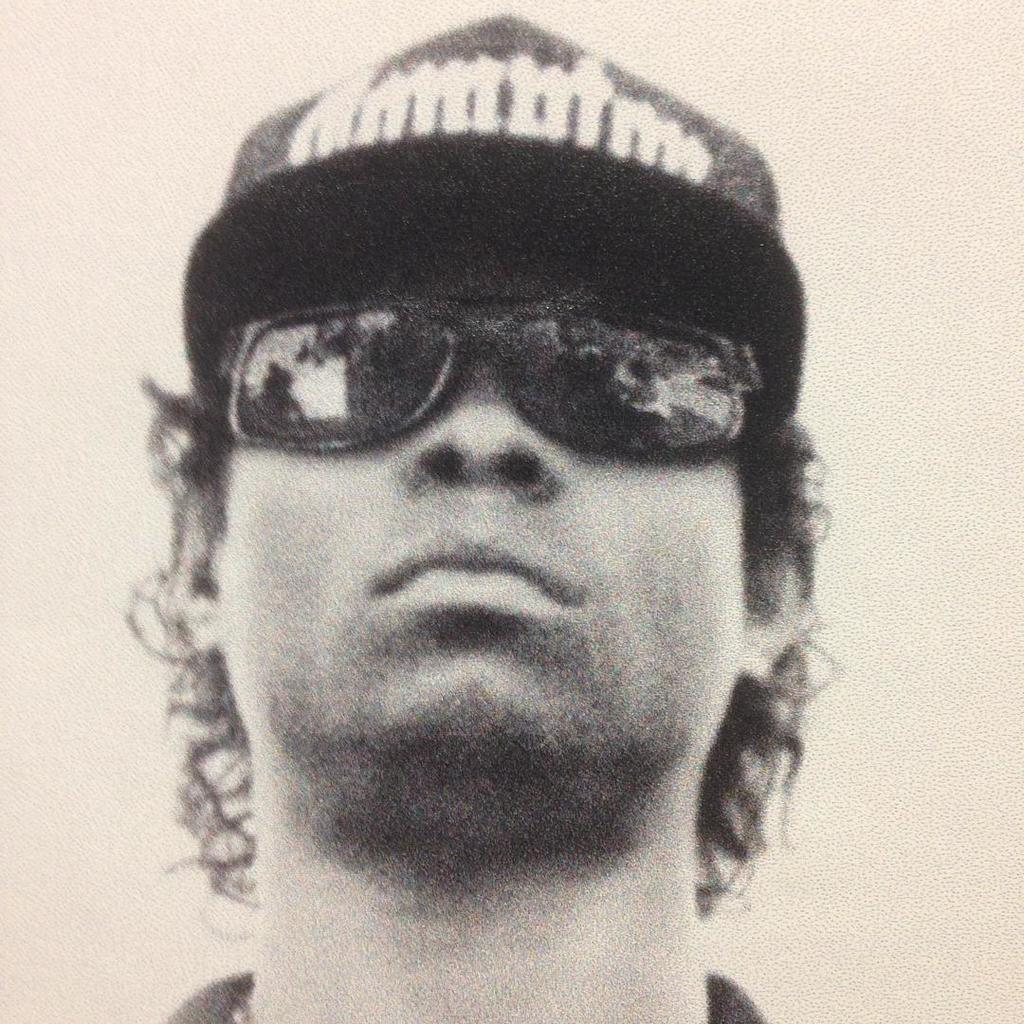What is the color scheme of the image? The image is in black and white. Can you describe the person in the image? There is a person in the image. What accessories is the person wearing? The person is wearing a cap and goggles. What type of celery is the person eating in the image? There is no celery present in the image. Why is the person crying in the image? The person is not crying in the image; there is no indication of emotion. 